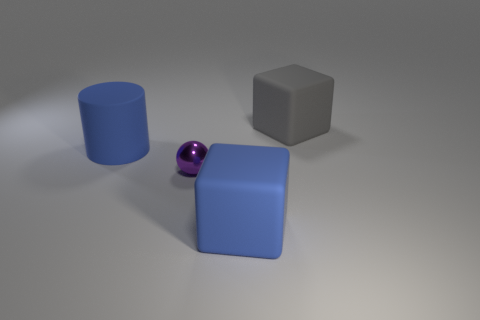Add 2 large gray blocks. How many objects exist? 6 Subtract all cylinders. How many objects are left? 3 Add 4 metallic spheres. How many metallic spheres are left? 5 Add 2 tiny brown things. How many tiny brown things exist? 2 Subtract 0 purple cubes. How many objects are left? 4 Subtract all purple spheres. Subtract all big blue rubber objects. How many objects are left? 1 